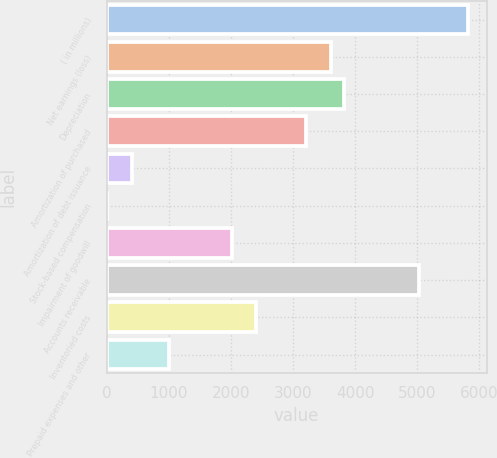<chart> <loc_0><loc_0><loc_500><loc_500><bar_chart><fcel>( in millions)<fcel>Net earnings (loss)<fcel>Depreciation<fcel>Amortization of purchased<fcel>Amortization of debt issuance<fcel>Stock-based compensation<fcel>Impairment of goodwill<fcel>Accounts receivable<fcel>Inventoried costs<fcel>Prepaid expenses and other<nl><fcel>5828.45<fcel>3617.78<fcel>3818.75<fcel>3215.84<fcel>402.26<fcel>0.32<fcel>2010.02<fcel>5024.57<fcel>2411.96<fcel>1005.17<nl></chart> 